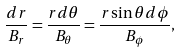<formula> <loc_0><loc_0><loc_500><loc_500>\frac { d r } { B _ { r } } = \frac { r d \theta } { B _ { \theta } } = \frac { r \sin \theta d \phi } { B _ { \phi } } ,</formula> 